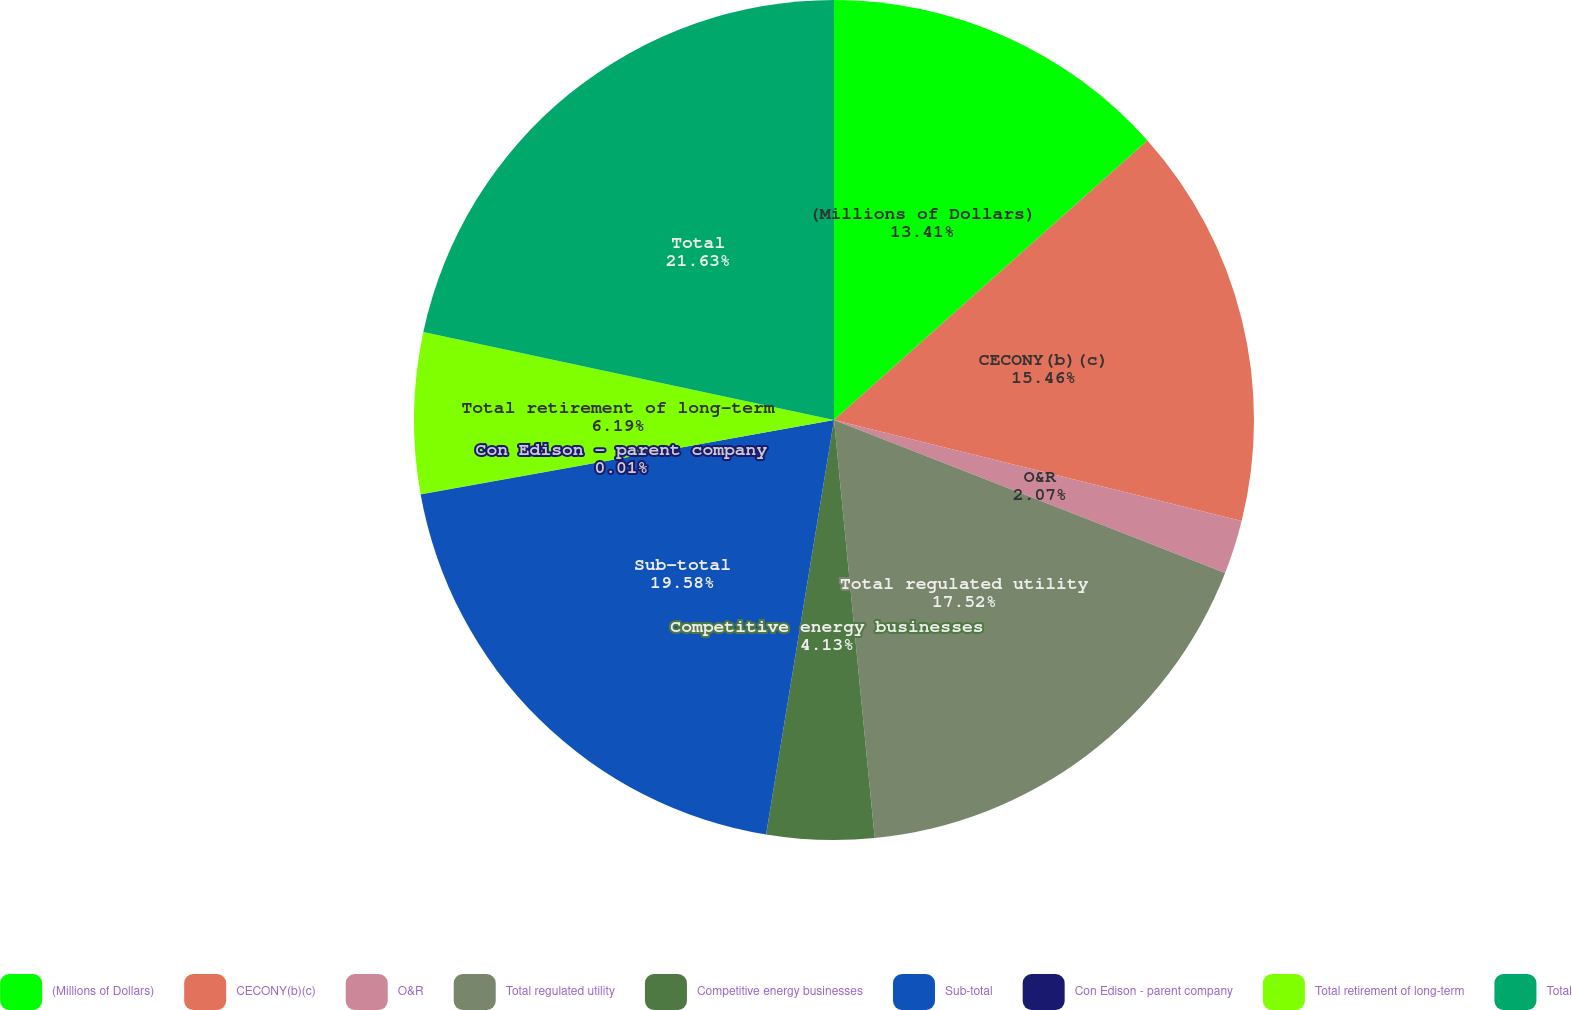Convert chart. <chart><loc_0><loc_0><loc_500><loc_500><pie_chart><fcel>(Millions of Dollars)<fcel>CECONY(b)(c)<fcel>O&R<fcel>Total regulated utility<fcel>Competitive energy businesses<fcel>Sub-total<fcel>Con Edison - parent company<fcel>Total retirement of long-term<fcel>Total<nl><fcel>13.41%<fcel>15.46%<fcel>2.07%<fcel>17.52%<fcel>4.13%<fcel>19.58%<fcel>0.01%<fcel>6.19%<fcel>21.64%<nl></chart> 